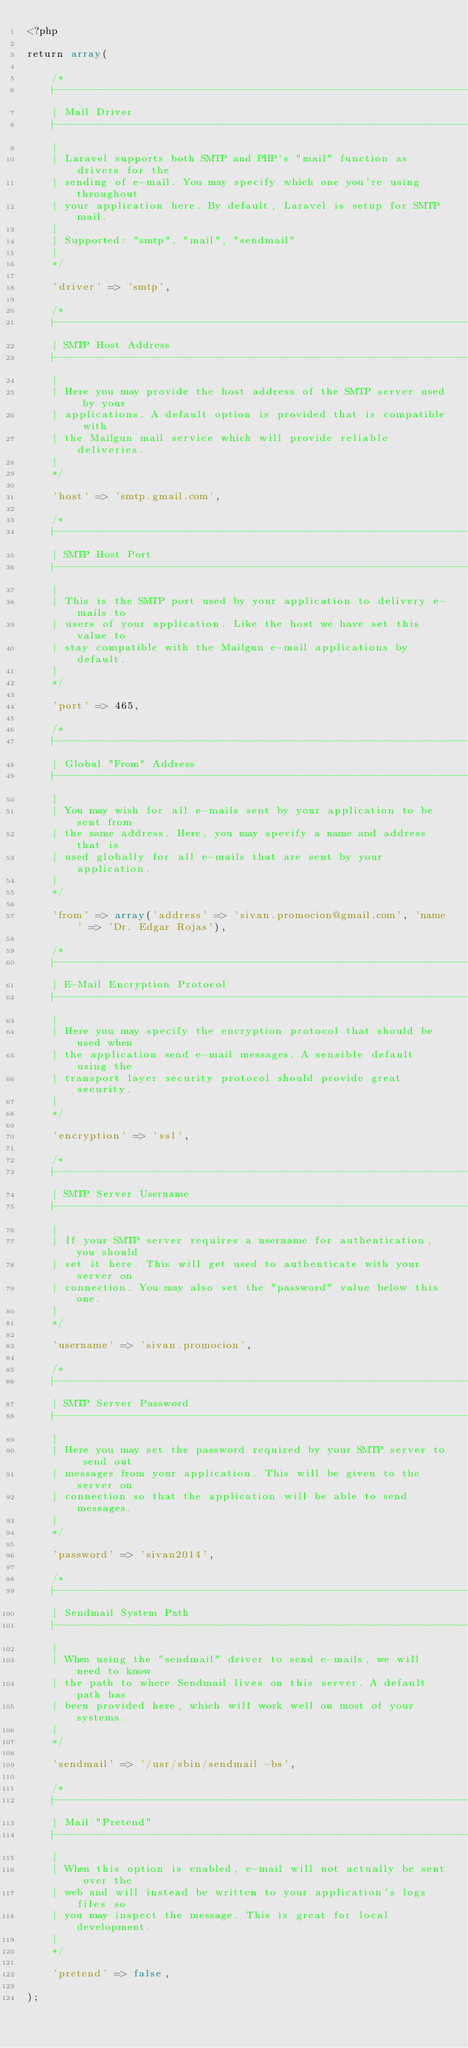<code> <loc_0><loc_0><loc_500><loc_500><_PHP_><?php

return array(

	/*
	|--------------------------------------------------------------------------
	| Mail Driver
	|--------------------------------------------------------------------------
	|
	| Laravel supports both SMTP and PHP's "mail" function as drivers for the
	| sending of e-mail. You may specify which one you're using throughout
	| your application here. By default, Laravel is setup for SMTP mail.
	|
	| Supported: "smtp", "mail", "sendmail"
	|
	*/

	'driver' => 'smtp',

	/*
	|--------------------------------------------------------------------------
	| SMTP Host Address
	|--------------------------------------------------------------------------
	|
	| Here you may provide the host address of the SMTP server used by your
	| applications. A default option is provided that is compatible with
	| the Mailgun mail service which will provide reliable deliveries.
	|
	*/

	'host' => 'smtp.gmail.com',

	/*
	|--------------------------------------------------------------------------
	| SMTP Host Port
	|--------------------------------------------------------------------------
	|
	| This is the SMTP port used by your application to delivery e-mails to
	| users of your application. Like the host we have set this value to
	| stay compatible with the Mailgun e-mail applications by default.
	|
	*/

	'port' => 465,

	/*
	|--------------------------------------------------------------------------
	| Global "From" Address
	|--------------------------------------------------------------------------
	|
	| You may wish for all e-mails sent by your application to be sent from
	| the same address. Here, you may specify a name and address that is
	| used globally for all e-mails that are sent by your application.
	|
	*/

	'from' => array('address' => 'sivan.promocion@gmail.com', 'name' => 'Dr. Edgar Rojas'),

	/*
	|--------------------------------------------------------------------------
	| E-Mail Encryption Protocol
	|--------------------------------------------------------------------------
	|
	| Here you may specify the encryption protocol that should be used when
	| the application send e-mail messages. A sensible default using the
	| transport layer security protocol should provide great security.
	|
	*/

	'encryption' => 'ssl',

	/*
	|--------------------------------------------------------------------------
	| SMTP Server Username
	|--------------------------------------------------------------------------
	|
	| If your SMTP server requires a username for authentication, you should
	| set it here. This will get used to authenticate with your server on
	| connection. You may also set the "password" value below this one.
	|
	*/

	'username' => 'sivan.promocion',

	/*
	|--------------------------------------------------------------------------
	| SMTP Server Password
	|--------------------------------------------------------------------------
	|
	| Here you may set the password required by your SMTP server to send out
	| messages from your application. This will be given to the server on
	| connection so that the application will be able to send messages.
	|
	*/

	'password' => 'sivan2014',

	/*
	|--------------------------------------------------------------------------
	| Sendmail System Path
	|--------------------------------------------------------------------------
	|
	| When using the "sendmail" driver to send e-mails, we will need to know
	| the path to where Sendmail lives on this server. A default path has
	| been provided here, which will work well on most of your systems.
	|
	*/

	'sendmail' => '/usr/sbin/sendmail -bs',

	/*
	|--------------------------------------------------------------------------
	| Mail "Pretend"
	|--------------------------------------------------------------------------
	|
	| When this option is enabled, e-mail will not actually be sent over the
	| web and will instead be written to your application's logs files so
	| you may inspect the message. This is great for local development.
	|
	*/

	'pretend' => false,

);
</code> 